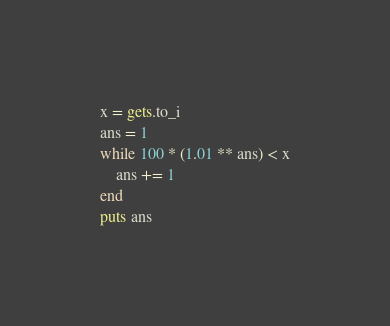Convert code to text. <code><loc_0><loc_0><loc_500><loc_500><_Ruby_>x = gets.to_i 
ans = 1
while 100 * (1.01 ** ans) < x
	ans += 1
end
puts ans</code> 